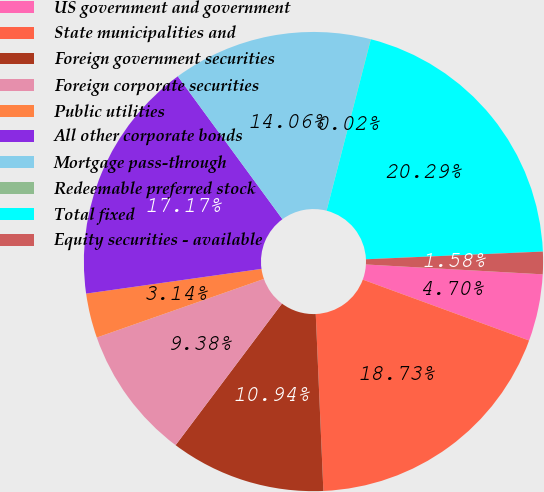<chart> <loc_0><loc_0><loc_500><loc_500><pie_chart><fcel>US government and government<fcel>State municipalities and<fcel>Foreign government securities<fcel>Foreign corporate securities<fcel>Public utilities<fcel>All other corporate bonds<fcel>Mortgage pass-through<fcel>Redeemable preferred stock<fcel>Total fixed<fcel>Equity securities - available<nl><fcel>4.7%<fcel>18.73%<fcel>10.94%<fcel>9.38%<fcel>3.14%<fcel>17.17%<fcel>14.06%<fcel>0.02%<fcel>20.29%<fcel>1.58%<nl></chart> 